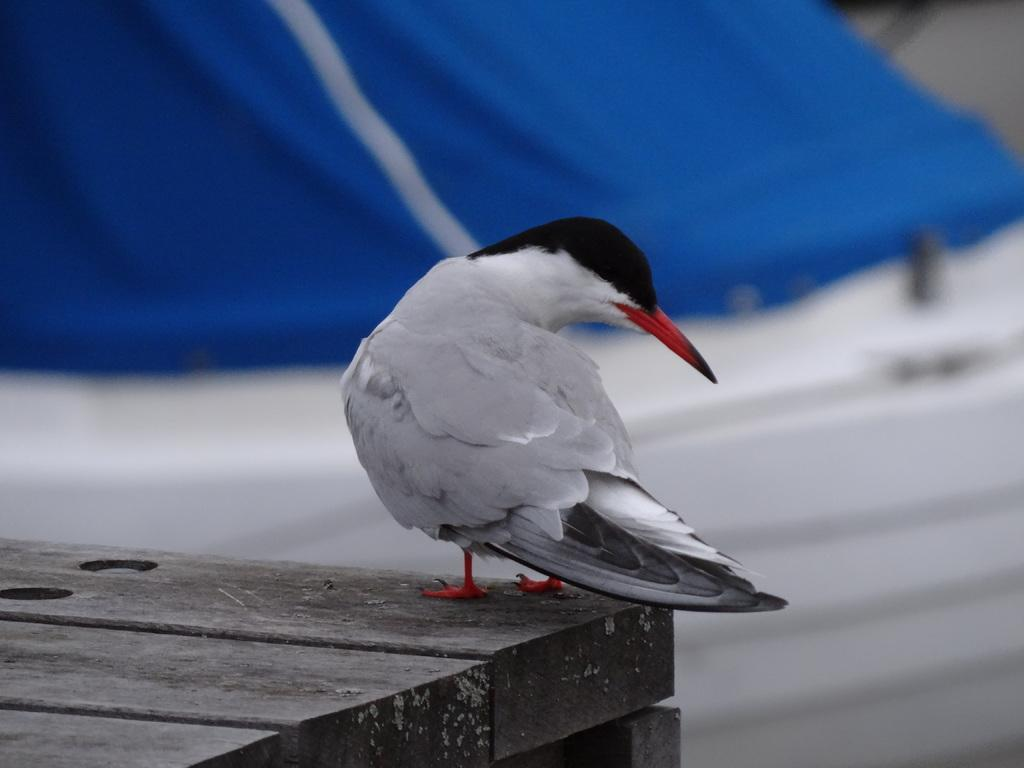What type of animal is standing in the image? There is a bird standing in the image. What is the surface beneath the bird made of? The surface beneath the bird is wooden. Can you describe the background of the image? The background of the image is blurry. What is the bird's income in the image? There is no information about the bird's income in the image. Birds do not have income. 